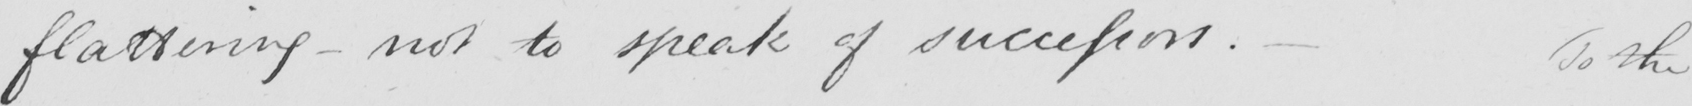What is written in this line of handwriting? flattering  _  not to speak of successors .  _  To the 